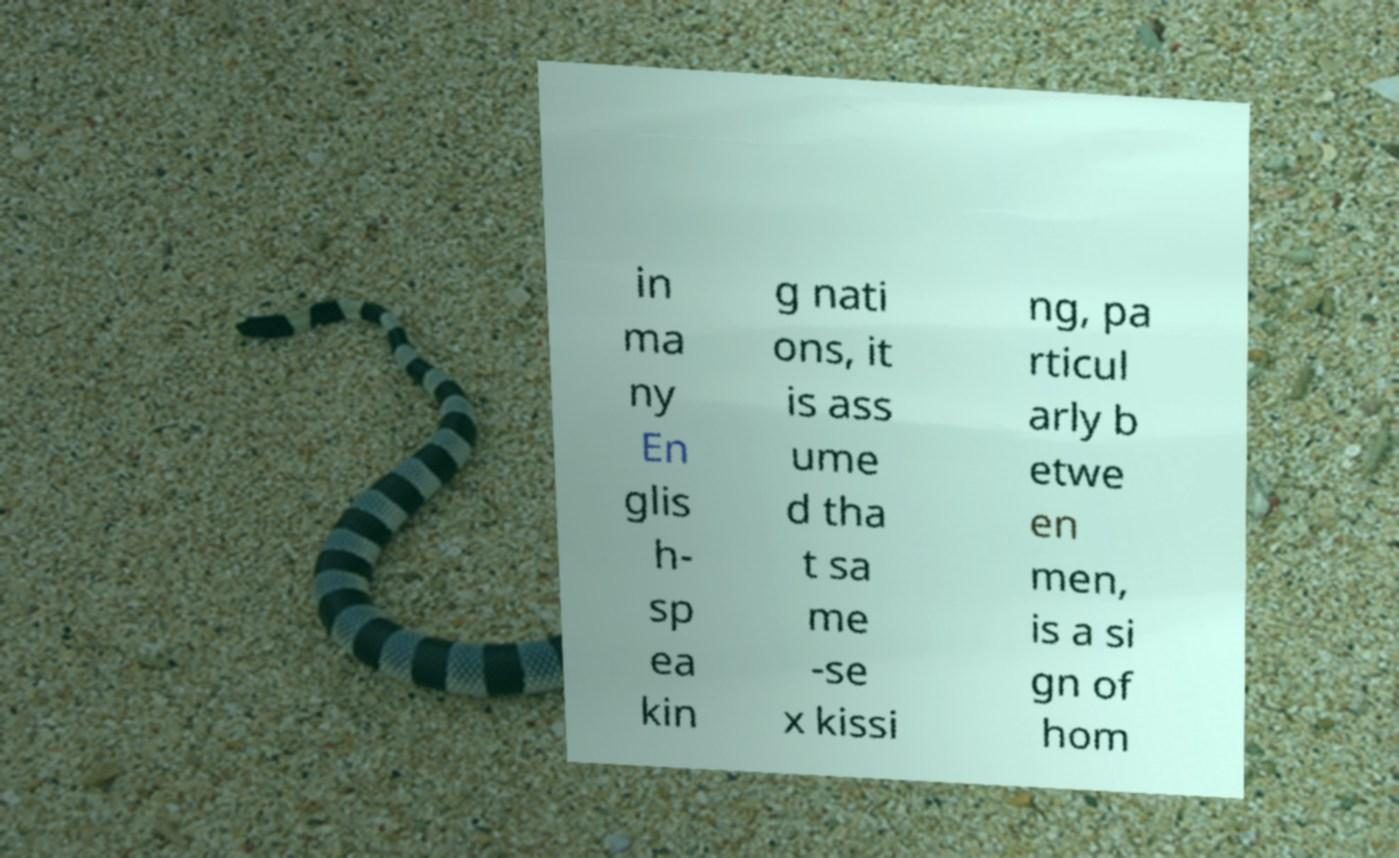Could you extract and type out the text from this image? in ma ny En glis h- sp ea kin g nati ons, it is ass ume d tha t sa me -se x kissi ng, pa rticul arly b etwe en men, is a si gn of hom 